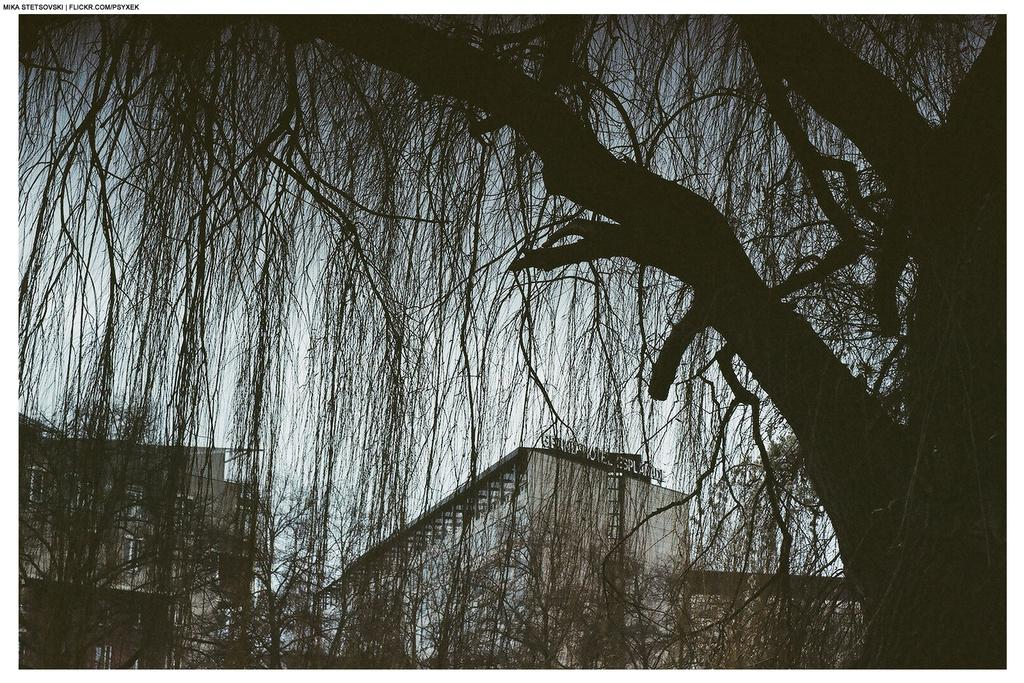What type of structures can be seen in the image? There are buildings in the image. What other natural elements are present in the image? There are trees in the image. What can be seen in the distance in the image? The sky is visible in the background of the image. What type of animal can be seen swimming in the river in the image? There is no river or animal present in the image; it features buildings, trees, and the sky. 